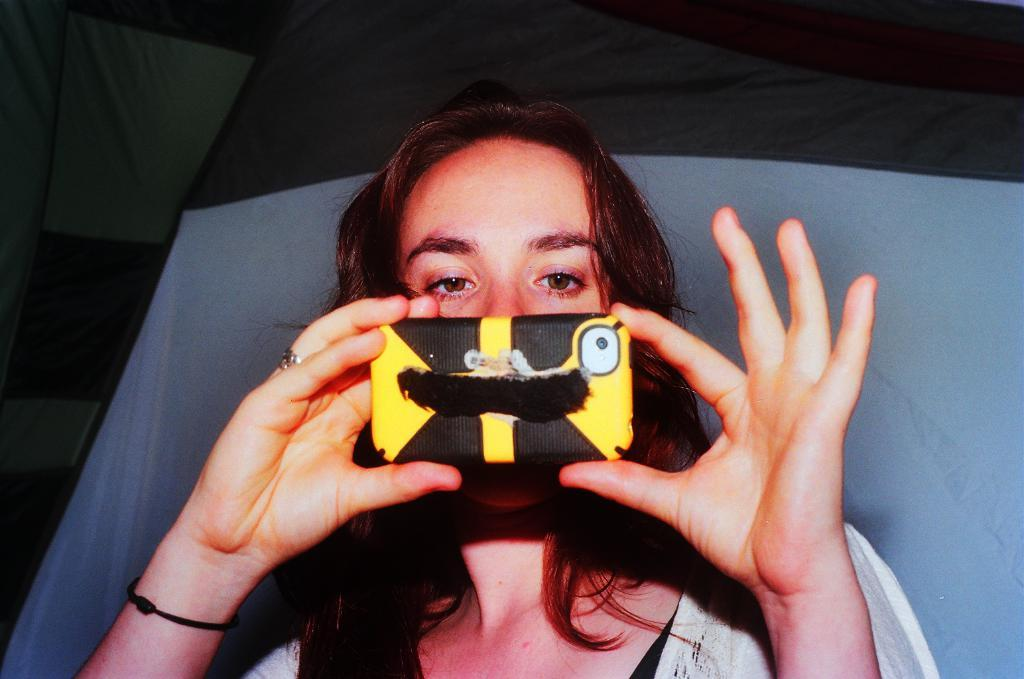Who is present in the image? There is a lady in the image. What is the lady holding in her hand? The lady is holding a mobile in her hand. What can be seen in the background of the image? There is a curtain in the background of the image. How many books can be seen on the lady's head in the image? There are no books visible on the lady's head in the image. What color is the lady's eye in the image? The lady's eye color cannot be determined from the image, as it is not visible. 